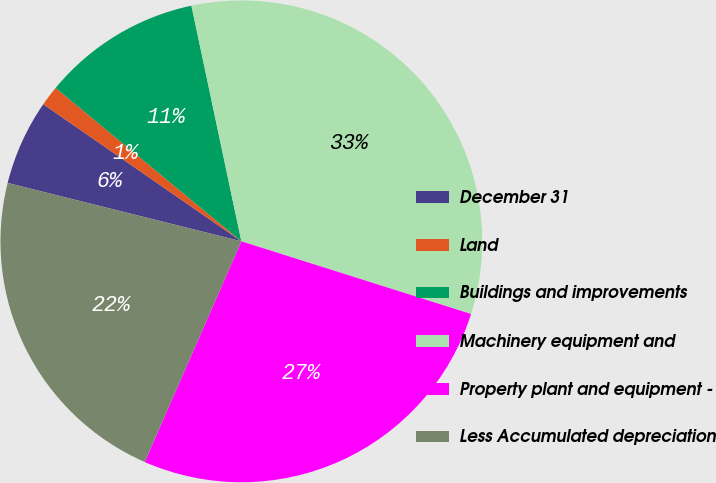Convert chart. <chart><loc_0><loc_0><loc_500><loc_500><pie_chart><fcel>December 31<fcel>Land<fcel>Buildings and improvements<fcel>Machinery equipment and<fcel>Property plant and equipment -<fcel>Less Accumulated depreciation<nl><fcel>5.74%<fcel>1.35%<fcel>10.69%<fcel>33.2%<fcel>26.7%<fcel>22.32%<nl></chart> 